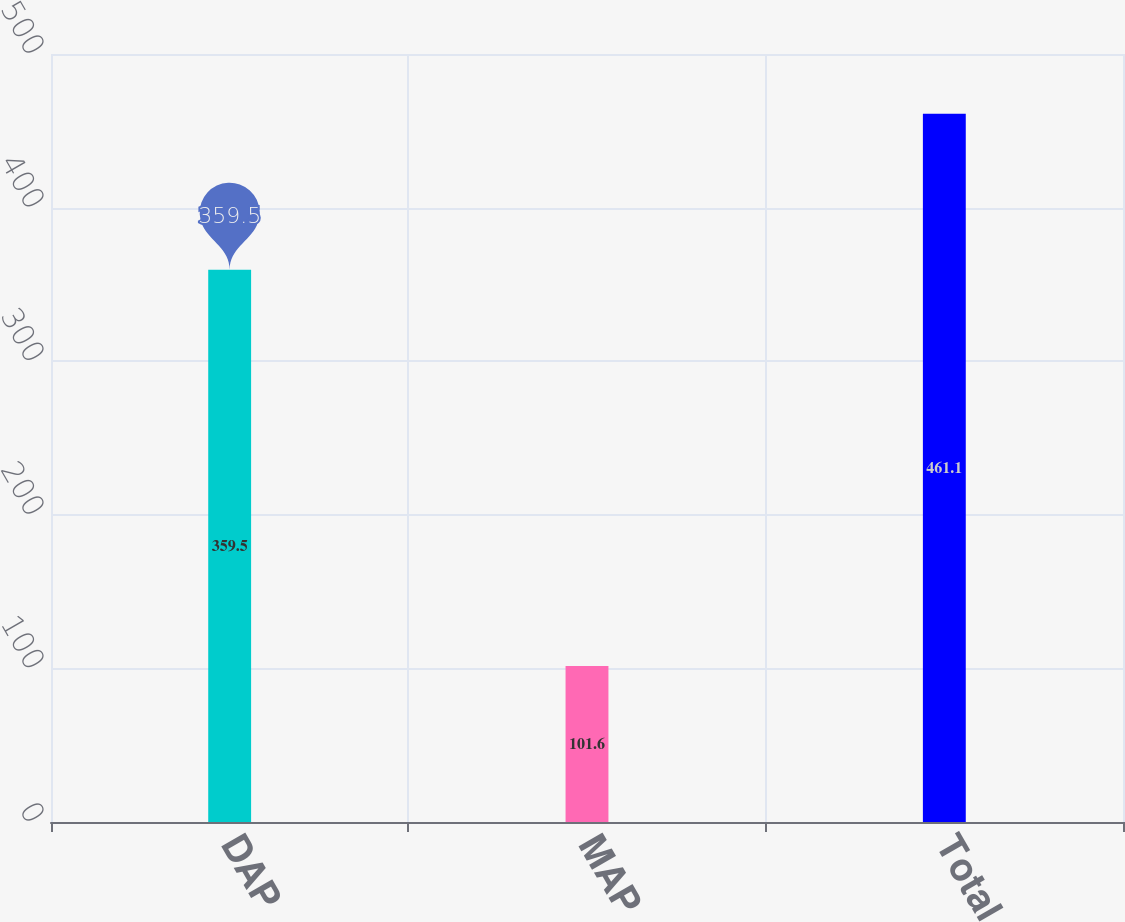Convert chart. <chart><loc_0><loc_0><loc_500><loc_500><bar_chart><fcel>DAP<fcel>MAP<fcel>Total<nl><fcel>359.5<fcel>101.6<fcel>461.1<nl></chart> 